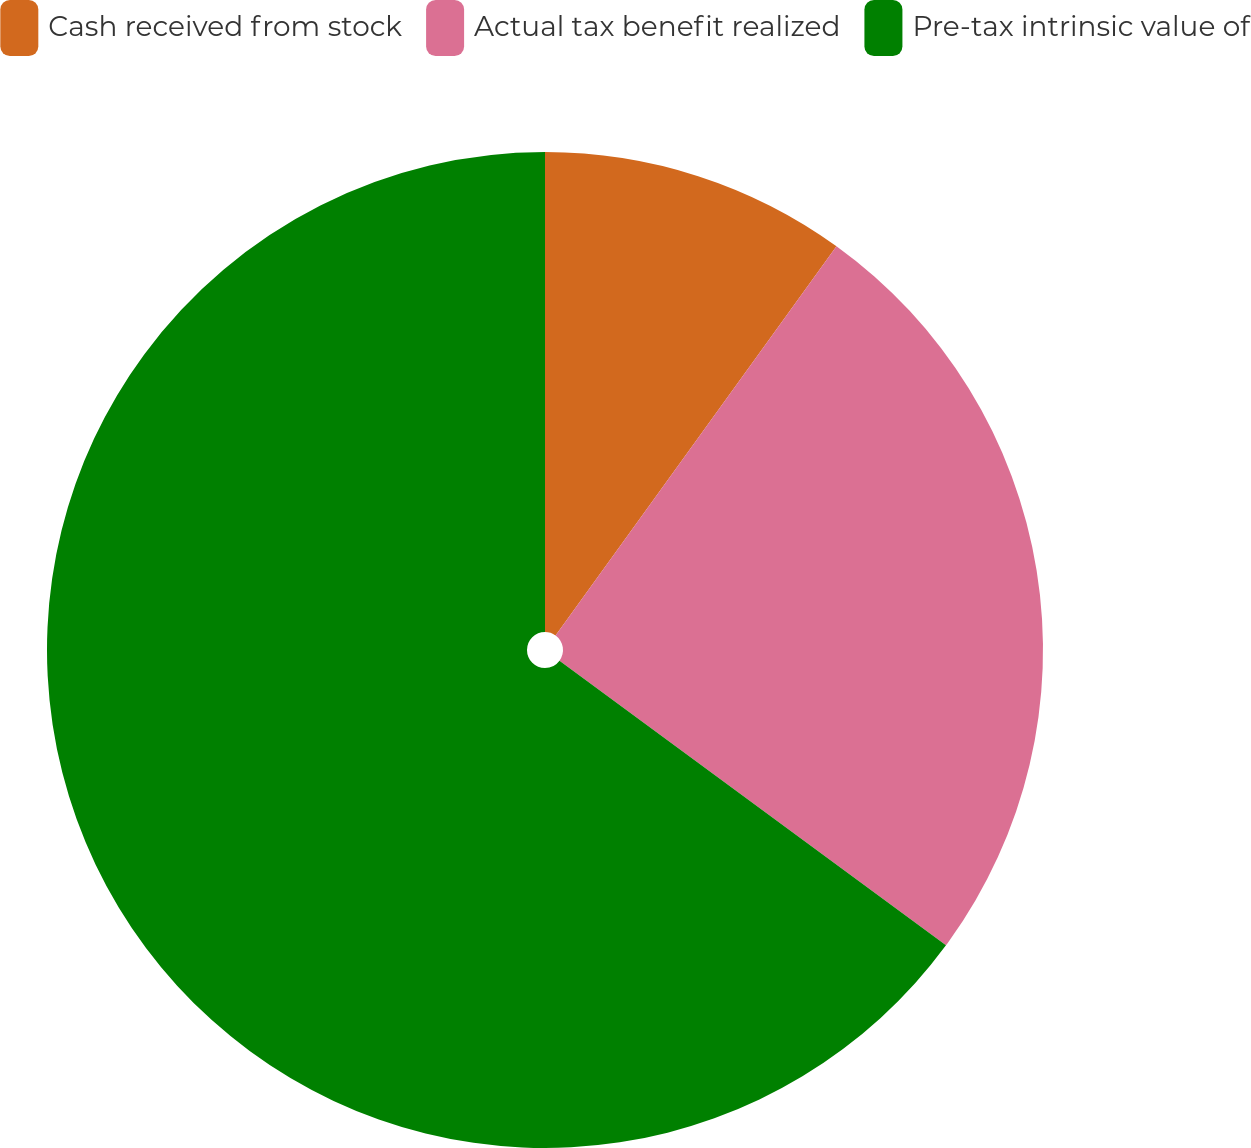Convert chart to OTSL. <chart><loc_0><loc_0><loc_500><loc_500><pie_chart><fcel>Cash received from stock<fcel>Actual tax benefit realized<fcel>Pre-tax intrinsic value of<nl><fcel>9.95%<fcel>25.15%<fcel>64.89%<nl></chart> 